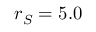<formula> <loc_0><loc_0><loc_500><loc_500>r _ { S } = 5 . 0</formula> 